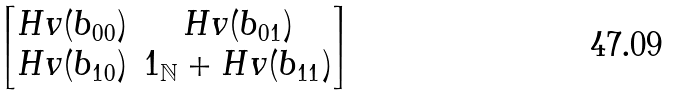<formula> <loc_0><loc_0><loc_500><loc_500>\begin{bmatrix} H v ( b _ { 0 0 } ) & H v ( b _ { 0 1 } ) \\ H v ( b _ { 1 0 } ) & 1 _ { \mathbb { N } } + H v ( b _ { 1 1 } ) \end{bmatrix}</formula> 